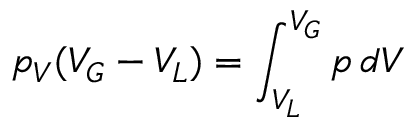Convert formula to latex. <formula><loc_0><loc_0><loc_500><loc_500>p _ { V } ( V _ { G } - V _ { L } ) = \int _ { V _ { L } } ^ { V _ { G } } p \, d V</formula> 